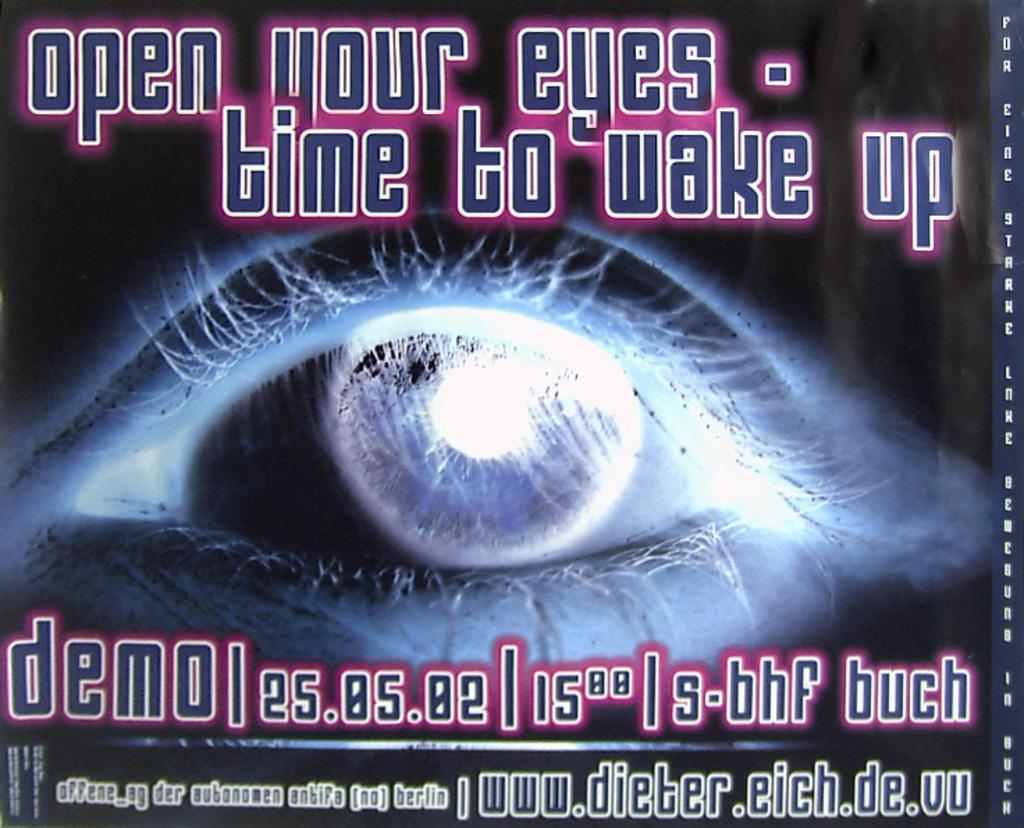<image>
Write a terse but informative summary of the picture. A picture of an eye with the caption open your eyes - time to wake up. 